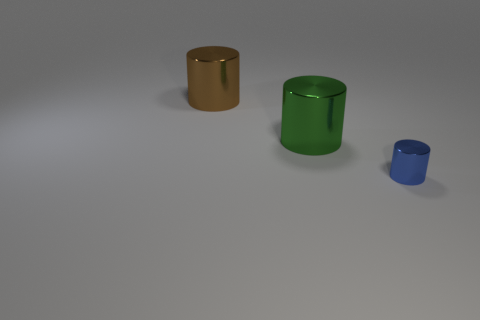Are there any green cubes that have the same size as the green shiny thing?
Provide a short and direct response. No. What material is the other brown thing that is the same shape as the small shiny thing?
Provide a short and direct response. Metal. What shape is the other thing that is the same size as the brown object?
Make the answer very short. Cylinder. Are there any gray things that have the same shape as the blue object?
Offer a terse response. No. There is a large thing to the left of the large green object that is to the right of the large brown shiny cylinder; what is its shape?
Your answer should be very brief. Cylinder. How many large metallic cylinders are behind the metal object in front of the large green shiny thing?
Keep it short and to the point. 2. What number of cylinders are either blue things or tiny yellow things?
Offer a very short reply. 1. There is a object that is both behind the blue thing and in front of the big brown metal object; what is its color?
Offer a terse response. Green. Are there any other things that are the same color as the tiny metal cylinder?
Provide a short and direct response. No. The tiny metal cylinder on the right side of the shiny cylinder behind the big green cylinder is what color?
Offer a very short reply. Blue. 